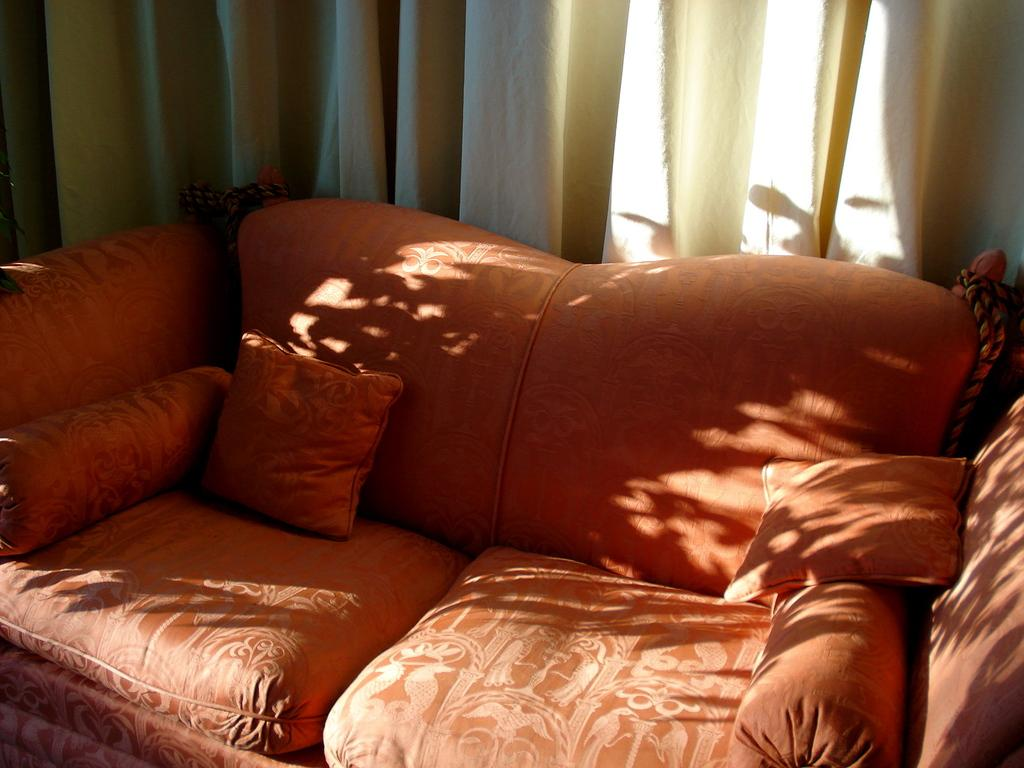Where was the image taken? The image was taken inside a room. What furniture is present in the room? There is a sofa in the room. What is the color of the sofa? The sofa is orange in color. Are there any decorative items on the sofa? Yes, there are pillows on the sofa. What can be seen in the background of the room? There is a curtain in the background. What type of shop can be seen in the image? There is no shop present in the image; it is taken inside a room with a sofa, pillows, and a curtain. 